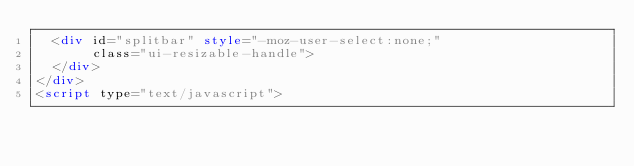<code> <loc_0><loc_0><loc_500><loc_500><_HTML_>  <div id="splitbar" style="-moz-user-select:none;" 
       class="ui-resizable-handle">
  </div>
</div>
<script type="text/javascript"></code> 